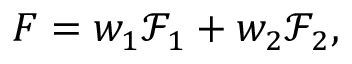<formula> <loc_0><loc_0><loc_500><loc_500>F = w _ { 1 } \mathcal { F } _ { 1 } + w _ { 2 } \mathcal { F } _ { 2 } ,</formula> 